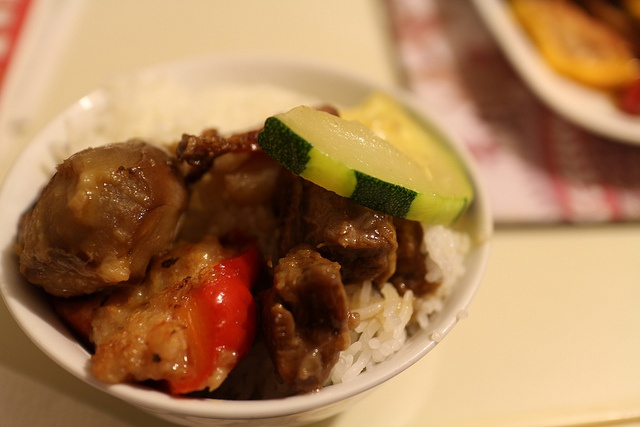Describe the objects in this image and their specific colors. I can see bowl in salmon, maroon, black, and tan tones and dining table in salmon, tan, maroon, and gray tones in this image. 